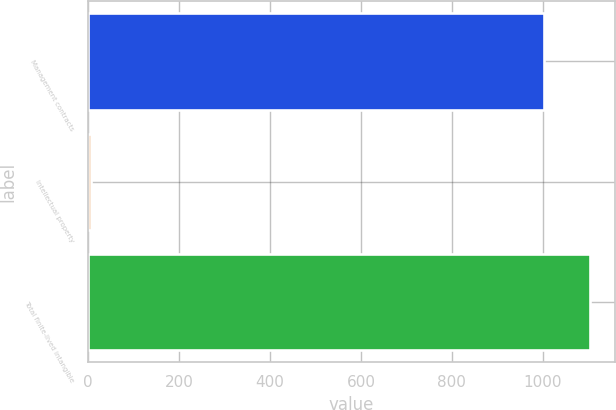<chart> <loc_0><loc_0><loc_500><loc_500><bar_chart><fcel>Management contracts<fcel>Intellectual property<fcel>Total finite-lived intangible<nl><fcel>1003<fcel>6<fcel>1103.3<nl></chart> 